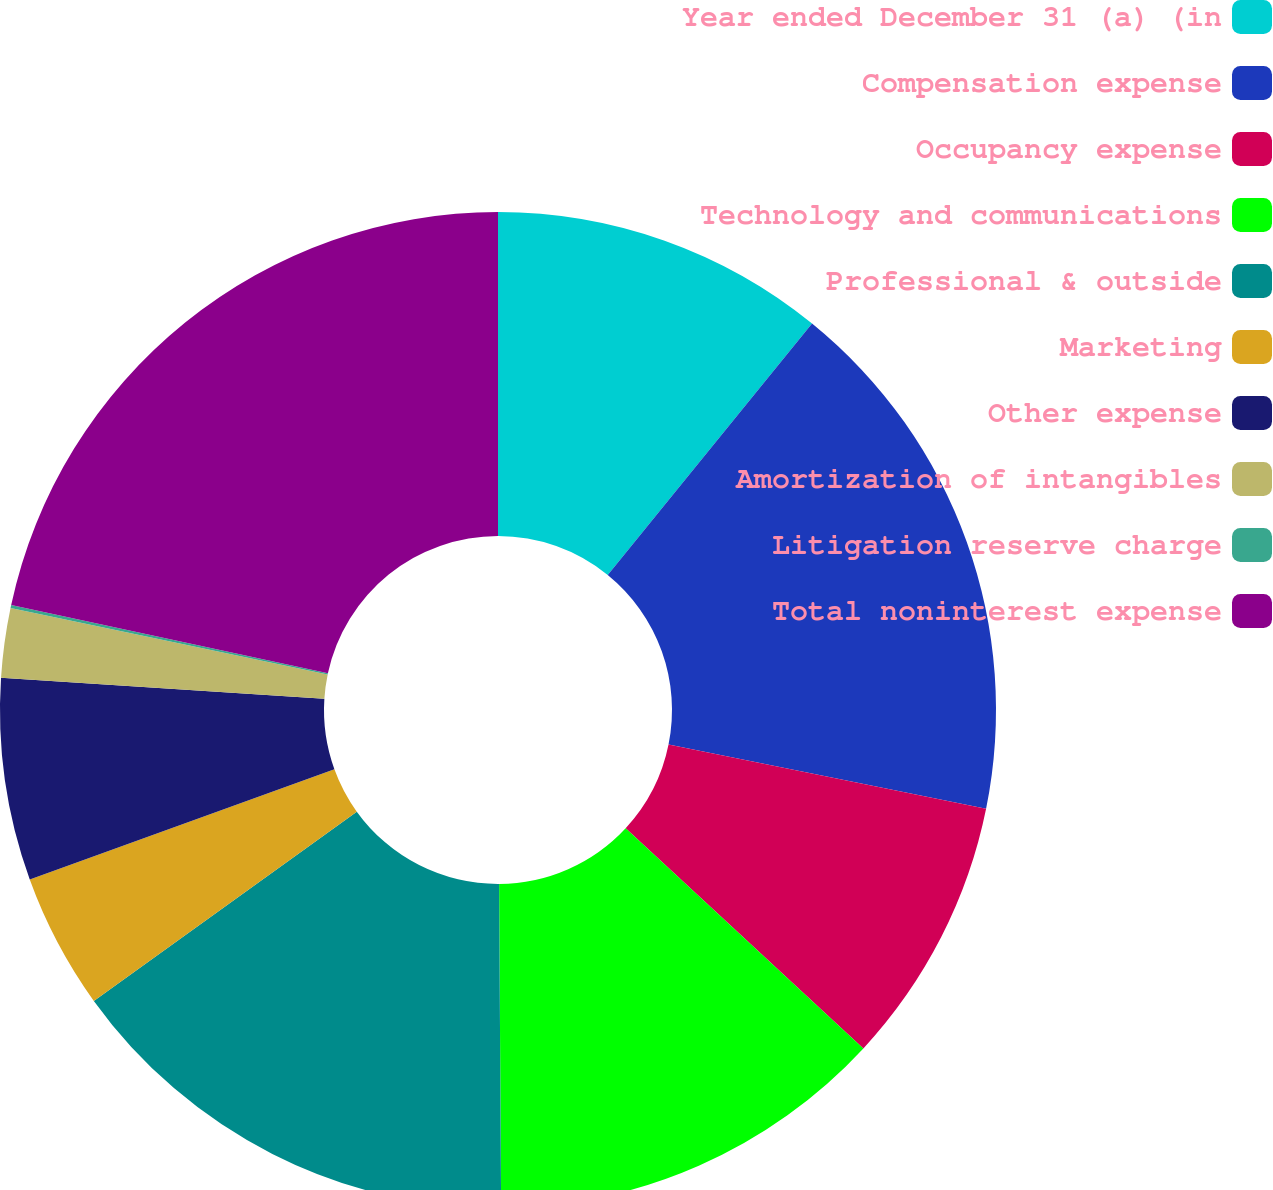<chart> <loc_0><loc_0><loc_500><loc_500><pie_chart><fcel>Year ended December 31 (a) (in<fcel>Compensation expense<fcel>Occupancy expense<fcel>Technology and communications<fcel>Professional & outside<fcel>Marketing<fcel>Other expense<fcel>Amortization of intangibles<fcel>Litigation reserve charge<fcel>Total noninterest expense<nl><fcel>10.86%<fcel>17.32%<fcel>8.71%<fcel>13.01%<fcel>15.17%<fcel>4.4%<fcel>6.56%<fcel>2.25%<fcel>0.1%<fcel>21.62%<nl></chart> 